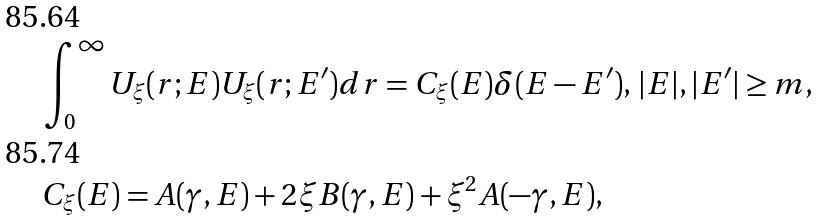Convert formula to latex. <formula><loc_0><loc_0><loc_500><loc_500>& \int _ { 0 } ^ { \infty } U _ { \xi } ( r ; E ) U _ { \xi } ( r ; E ^ { \prime } ) d r = C _ { \xi } ( E ) \delta ( E - E ^ { \prime } ) , \, | E | , | E ^ { \prime } | \geq m , \\ & C _ { \xi } ( E ) = A ( \gamma , E ) + 2 \xi B ( \gamma , E ) + \xi ^ { 2 } A ( - \gamma , E ) ,</formula> 